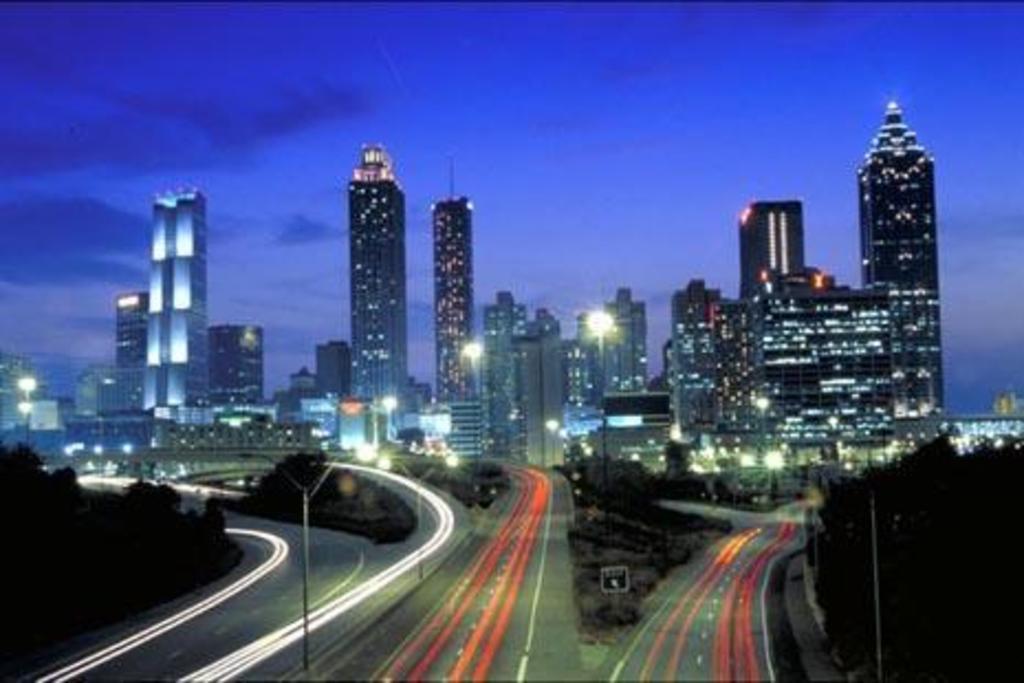How would you summarize this image in a sentence or two? In the foreground I can see poles, trees and vehicles on the road. In the background I can see buildings and towers. On the top I can see the sky. This image is taken during night. 